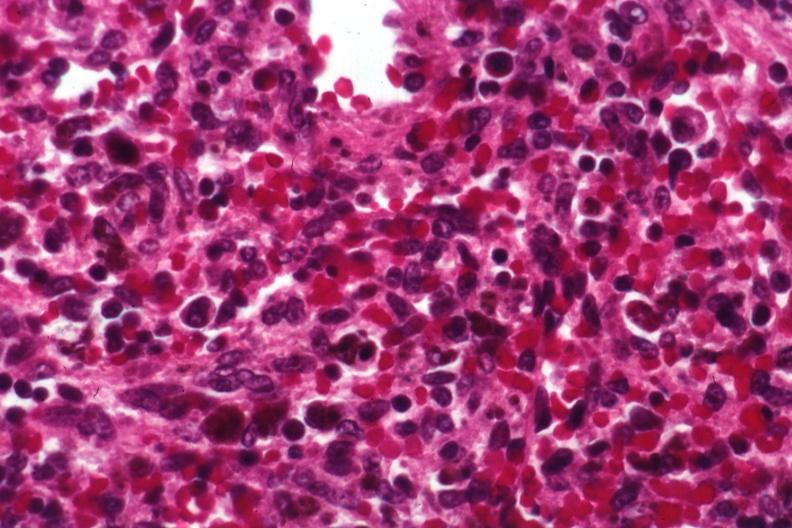s this photo present?
Answer the question using a single word or phrase. No 